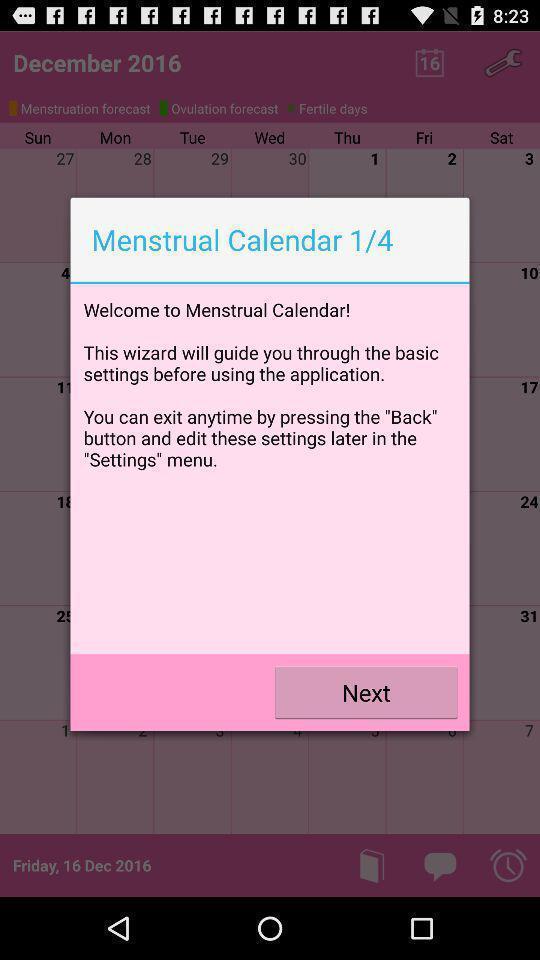Describe the content in this image. Pop up showing information. 